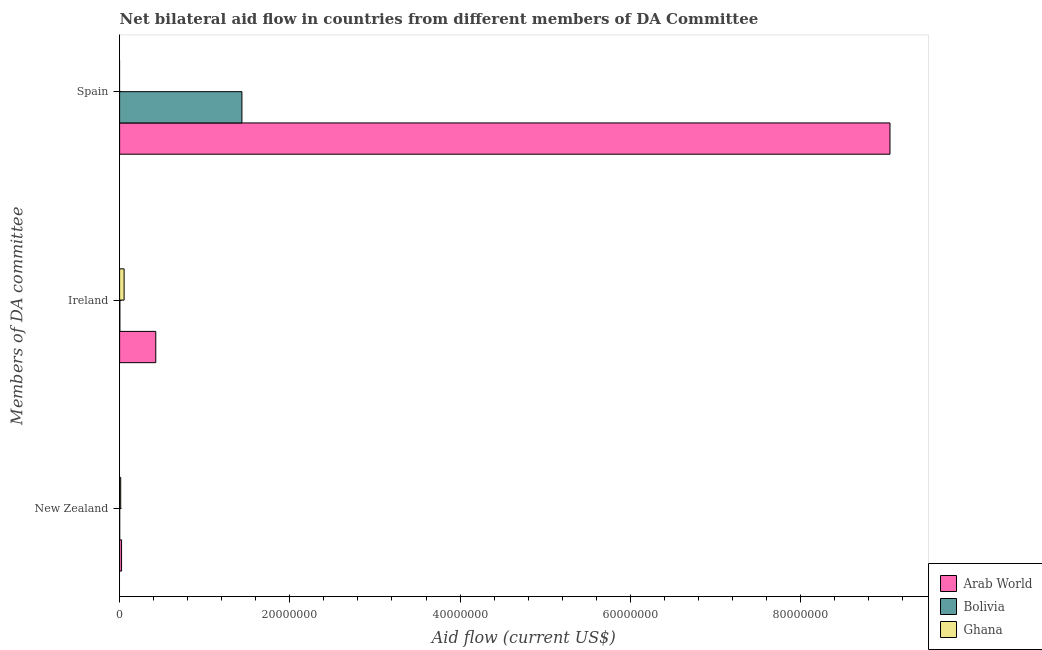How many different coloured bars are there?
Offer a very short reply. 3. Are the number of bars on each tick of the Y-axis equal?
Offer a very short reply. No. How many bars are there on the 1st tick from the top?
Give a very brief answer. 2. How many bars are there on the 2nd tick from the bottom?
Give a very brief answer. 3. What is the label of the 3rd group of bars from the top?
Make the answer very short. New Zealand. What is the amount of aid provided by ireland in Bolivia?
Keep it short and to the point. 3.00e+04. Across all countries, what is the maximum amount of aid provided by new zealand?
Your answer should be very brief. 2.30e+05. In which country was the amount of aid provided by new zealand maximum?
Your response must be concise. Arab World. What is the total amount of aid provided by ireland in the graph?
Your answer should be very brief. 4.81e+06. What is the difference between the amount of aid provided by ireland in Ghana and that in Arab World?
Your response must be concise. -3.72e+06. What is the difference between the amount of aid provided by spain in Ghana and the amount of aid provided by new zealand in Arab World?
Make the answer very short. -2.30e+05. What is the average amount of aid provided by new zealand per country?
Offer a terse response. 1.23e+05. What is the difference between the amount of aid provided by spain and amount of aid provided by ireland in Arab World?
Provide a short and direct response. 8.63e+07. What is the ratio of the amount of aid provided by new zealand in Arab World to that in Bolivia?
Give a very brief answer. 23. What is the difference between the highest and the lowest amount of aid provided by spain?
Make the answer very short. 9.05e+07. Is the sum of the amount of aid provided by ireland in Ghana and Bolivia greater than the maximum amount of aid provided by new zealand across all countries?
Provide a short and direct response. Yes. Are all the bars in the graph horizontal?
Keep it short and to the point. Yes. How many countries are there in the graph?
Ensure brevity in your answer.  3. Are the values on the major ticks of X-axis written in scientific E-notation?
Provide a succinct answer. No. Does the graph contain grids?
Make the answer very short. No. How many legend labels are there?
Offer a terse response. 3. How are the legend labels stacked?
Keep it short and to the point. Vertical. What is the title of the graph?
Give a very brief answer. Net bilateral aid flow in countries from different members of DA Committee. What is the label or title of the X-axis?
Offer a very short reply. Aid flow (current US$). What is the label or title of the Y-axis?
Make the answer very short. Members of DA committee. What is the Aid flow (current US$) in Arab World in New Zealand?
Your answer should be very brief. 2.30e+05. What is the Aid flow (current US$) in Arab World in Ireland?
Give a very brief answer. 4.25e+06. What is the Aid flow (current US$) of Bolivia in Ireland?
Give a very brief answer. 3.00e+04. What is the Aid flow (current US$) in Ghana in Ireland?
Offer a very short reply. 5.30e+05. What is the Aid flow (current US$) in Arab World in Spain?
Provide a succinct answer. 9.05e+07. What is the Aid flow (current US$) in Bolivia in Spain?
Your answer should be very brief. 1.44e+07. Across all Members of DA committee, what is the maximum Aid flow (current US$) in Arab World?
Keep it short and to the point. 9.05e+07. Across all Members of DA committee, what is the maximum Aid flow (current US$) in Bolivia?
Give a very brief answer. 1.44e+07. Across all Members of DA committee, what is the maximum Aid flow (current US$) in Ghana?
Your answer should be compact. 5.30e+05. Across all Members of DA committee, what is the minimum Aid flow (current US$) of Ghana?
Ensure brevity in your answer.  0. What is the total Aid flow (current US$) in Arab World in the graph?
Give a very brief answer. 9.50e+07. What is the total Aid flow (current US$) of Bolivia in the graph?
Give a very brief answer. 1.44e+07. What is the difference between the Aid flow (current US$) in Arab World in New Zealand and that in Ireland?
Offer a very short reply. -4.02e+06. What is the difference between the Aid flow (current US$) of Bolivia in New Zealand and that in Ireland?
Offer a very short reply. -2.00e+04. What is the difference between the Aid flow (current US$) of Ghana in New Zealand and that in Ireland?
Keep it short and to the point. -4.00e+05. What is the difference between the Aid flow (current US$) of Arab World in New Zealand and that in Spain?
Offer a terse response. -9.03e+07. What is the difference between the Aid flow (current US$) of Bolivia in New Zealand and that in Spain?
Ensure brevity in your answer.  -1.44e+07. What is the difference between the Aid flow (current US$) of Arab World in Ireland and that in Spain?
Your answer should be very brief. -8.63e+07. What is the difference between the Aid flow (current US$) in Bolivia in Ireland and that in Spain?
Make the answer very short. -1.43e+07. What is the difference between the Aid flow (current US$) in Arab World in New Zealand and the Aid flow (current US$) in Bolivia in Ireland?
Your response must be concise. 2.00e+05. What is the difference between the Aid flow (current US$) in Arab World in New Zealand and the Aid flow (current US$) in Ghana in Ireland?
Your response must be concise. -3.00e+05. What is the difference between the Aid flow (current US$) of Bolivia in New Zealand and the Aid flow (current US$) of Ghana in Ireland?
Provide a short and direct response. -5.20e+05. What is the difference between the Aid flow (current US$) of Arab World in New Zealand and the Aid flow (current US$) of Bolivia in Spain?
Offer a very short reply. -1.41e+07. What is the difference between the Aid flow (current US$) in Arab World in Ireland and the Aid flow (current US$) in Bolivia in Spain?
Your response must be concise. -1.01e+07. What is the average Aid flow (current US$) of Arab World per Members of DA committee?
Offer a very short reply. 3.17e+07. What is the average Aid flow (current US$) in Bolivia per Members of DA committee?
Offer a very short reply. 4.80e+06. What is the average Aid flow (current US$) of Ghana per Members of DA committee?
Give a very brief answer. 2.20e+05. What is the difference between the Aid flow (current US$) of Arab World and Aid flow (current US$) of Bolivia in New Zealand?
Your response must be concise. 2.20e+05. What is the difference between the Aid flow (current US$) of Arab World and Aid flow (current US$) of Ghana in New Zealand?
Your response must be concise. 1.00e+05. What is the difference between the Aid flow (current US$) in Arab World and Aid flow (current US$) in Bolivia in Ireland?
Offer a terse response. 4.22e+06. What is the difference between the Aid flow (current US$) in Arab World and Aid flow (current US$) in Ghana in Ireland?
Keep it short and to the point. 3.72e+06. What is the difference between the Aid flow (current US$) in Bolivia and Aid flow (current US$) in Ghana in Ireland?
Your response must be concise. -5.00e+05. What is the difference between the Aid flow (current US$) of Arab World and Aid flow (current US$) of Bolivia in Spain?
Offer a terse response. 7.61e+07. What is the ratio of the Aid flow (current US$) in Arab World in New Zealand to that in Ireland?
Give a very brief answer. 0.05. What is the ratio of the Aid flow (current US$) of Ghana in New Zealand to that in Ireland?
Your answer should be compact. 0.25. What is the ratio of the Aid flow (current US$) of Arab World in New Zealand to that in Spain?
Keep it short and to the point. 0. What is the ratio of the Aid flow (current US$) in Bolivia in New Zealand to that in Spain?
Your answer should be very brief. 0. What is the ratio of the Aid flow (current US$) in Arab World in Ireland to that in Spain?
Your answer should be very brief. 0.05. What is the ratio of the Aid flow (current US$) of Bolivia in Ireland to that in Spain?
Your response must be concise. 0. What is the difference between the highest and the second highest Aid flow (current US$) in Arab World?
Give a very brief answer. 8.63e+07. What is the difference between the highest and the second highest Aid flow (current US$) of Bolivia?
Your answer should be compact. 1.43e+07. What is the difference between the highest and the lowest Aid flow (current US$) of Arab World?
Ensure brevity in your answer.  9.03e+07. What is the difference between the highest and the lowest Aid flow (current US$) of Bolivia?
Make the answer very short. 1.44e+07. What is the difference between the highest and the lowest Aid flow (current US$) of Ghana?
Provide a succinct answer. 5.30e+05. 